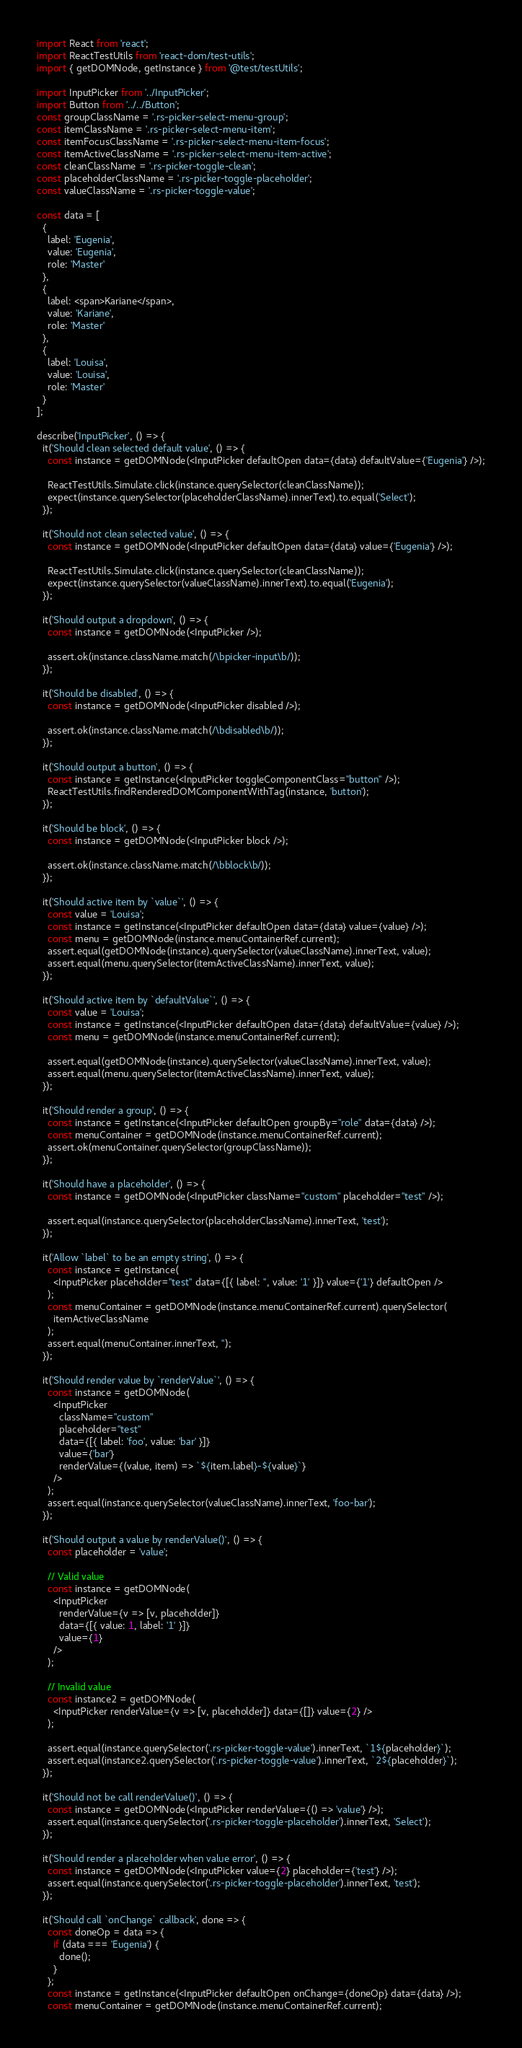Convert code to text. <code><loc_0><loc_0><loc_500><loc_500><_JavaScript_>import React from 'react';
import ReactTestUtils from 'react-dom/test-utils';
import { getDOMNode, getInstance } from '@test/testUtils';

import InputPicker from '../InputPicker';
import Button from '../../Button';
const groupClassName = '.rs-picker-select-menu-group';
const itemClassName = '.rs-picker-select-menu-item';
const itemFocusClassName = '.rs-picker-select-menu-item-focus';
const itemActiveClassName = '.rs-picker-select-menu-item-active';
const cleanClassName = '.rs-picker-toggle-clean';
const placeholderClassName = '.rs-picker-toggle-placeholder';
const valueClassName = '.rs-picker-toggle-value';

const data = [
  {
    label: 'Eugenia',
    value: 'Eugenia',
    role: 'Master'
  },
  {
    label: <span>Kariane</span>,
    value: 'Kariane',
    role: 'Master'
  },
  {
    label: 'Louisa',
    value: 'Louisa',
    role: 'Master'
  }
];

describe('InputPicker', () => {
  it('Should clean selected default value', () => {
    const instance = getDOMNode(<InputPicker defaultOpen data={data} defaultValue={'Eugenia'} />);

    ReactTestUtils.Simulate.click(instance.querySelector(cleanClassName));
    expect(instance.querySelector(placeholderClassName).innerText).to.equal('Select');
  });

  it('Should not clean selected value', () => {
    const instance = getDOMNode(<InputPicker defaultOpen data={data} value={'Eugenia'} />);

    ReactTestUtils.Simulate.click(instance.querySelector(cleanClassName));
    expect(instance.querySelector(valueClassName).innerText).to.equal('Eugenia');
  });

  it('Should output a dropdown', () => {
    const instance = getDOMNode(<InputPicker />);

    assert.ok(instance.className.match(/\bpicker-input\b/));
  });

  it('Should be disabled', () => {
    const instance = getDOMNode(<InputPicker disabled />);

    assert.ok(instance.className.match(/\bdisabled\b/));
  });

  it('Should output a button', () => {
    const instance = getInstance(<InputPicker toggleComponentClass="button" />);
    ReactTestUtils.findRenderedDOMComponentWithTag(instance, 'button');
  });

  it('Should be block', () => {
    const instance = getDOMNode(<InputPicker block />);

    assert.ok(instance.className.match(/\bblock\b/));
  });

  it('Should active item by `value`', () => {
    const value = 'Louisa';
    const instance = getInstance(<InputPicker defaultOpen data={data} value={value} />);
    const menu = getDOMNode(instance.menuContainerRef.current);
    assert.equal(getDOMNode(instance).querySelector(valueClassName).innerText, value);
    assert.equal(menu.querySelector(itemActiveClassName).innerText, value);
  });

  it('Should active item by `defaultValue`', () => {
    const value = 'Louisa';
    const instance = getInstance(<InputPicker defaultOpen data={data} defaultValue={value} />);
    const menu = getDOMNode(instance.menuContainerRef.current);

    assert.equal(getDOMNode(instance).querySelector(valueClassName).innerText, value);
    assert.equal(menu.querySelector(itemActiveClassName).innerText, value);
  });

  it('Should render a group', () => {
    const instance = getInstance(<InputPicker defaultOpen groupBy="role" data={data} />);
    const menuContainer = getDOMNode(instance.menuContainerRef.current);
    assert.ok(menuContainer.querySelector(groupClassName));
  });

  it('Should have a placeholder', () => {
    const instance = getDOMNode(<InputPicker className="custom" placeholder="test" />);

    assert.equal(instance.querySelector(placeholderClassName).innerText, 'test');
  });

  it('Allow `label` to be an empty string', () => {
    const instance = getInstance(
      <InputPicker placeholder="test" data={[{ label: '', value: '1' }]} value={'1'} defaultOpen />
    );
    const menuContainer = getDOMNode(instance.menuContainerRef.current).querySelector(
      itemActiveClassName
    );
    assert.equal(menuContainer.innerText, '');
  });

  it('Should render value by `renderValue`', () => {
    const instance = getDOMNode(
      <InputPicker
        className="custom"
        placeholder="test"
        data={[{ label: 'foo', value: 'bar' }]}
        value={'bar'}
        renderValue={(value, item) => `${item.label}-${value}`}
      />
    );
    assert.equal(instance.querySelector(valueClassName).innerText, 'foo-bar');
  });

  it('Should output a value by renderValue()', () => {
    const placeholder = 'value';

    // Valid value
    const instance = getDOMNode(
      <InputPicker
        renderValue={v => [v, placeholder]}
        data={[{ value: 1, label: '1' }]}
        value={1}
      />
    );

    // Invalid value
    const instance2 = getDOMNode(
      <InputPicker renderValue={v => [v, placeholder]} data={[]} value={2} />
    );

    assert.equal(instance.querySelector('.rs-picker-toggle-value').innerText, `1${placeholder}`);
    assert.equal(instance2.querySelector('.rs-picker-toggle-value').innerText, `2${placeholder}`);
  });

  it('Should not be call renderValue()', () => {
    const instance = getDOMNode(<InputPicker renderValue={() => 'value'} />);
    assert.equal(instance.querySelector('.rs-picker-toggle-placeholder').innerText, 'Select');
  });

  it('Should render a placeholder when value error', () => {
    const instance = getDOMNode(<InputPicker value={2} placeholder={'test'} />);
    assert.equal(instance.querySelector('.rs-picker-toggle-placeholder').innerText, 'test');
  });

  it('Should call `onChange` callback', done => {
    const doneOp = data => {
      if (data === 'Eugenia') {
        done();
      }
    };
    const instance = getInstance(<InputPicker defaultOpen onChange={doneOp} data={data} />);
    const menuContainer = getDOMNode(instance.menuContainerRef.current);
</code> 